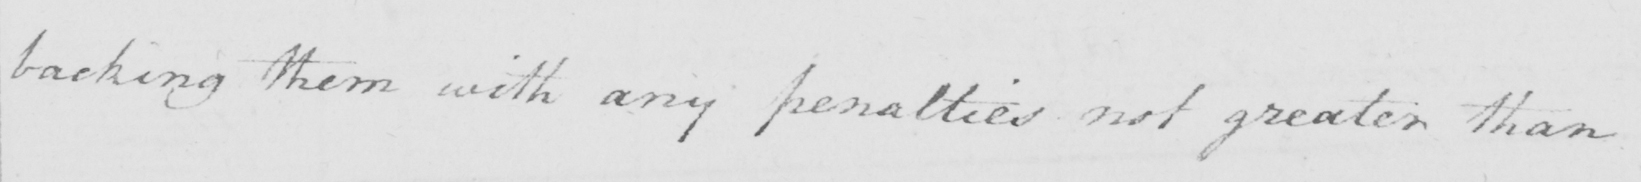Please provide the text content of this handwritten line. backing them with any penalties not greater than 